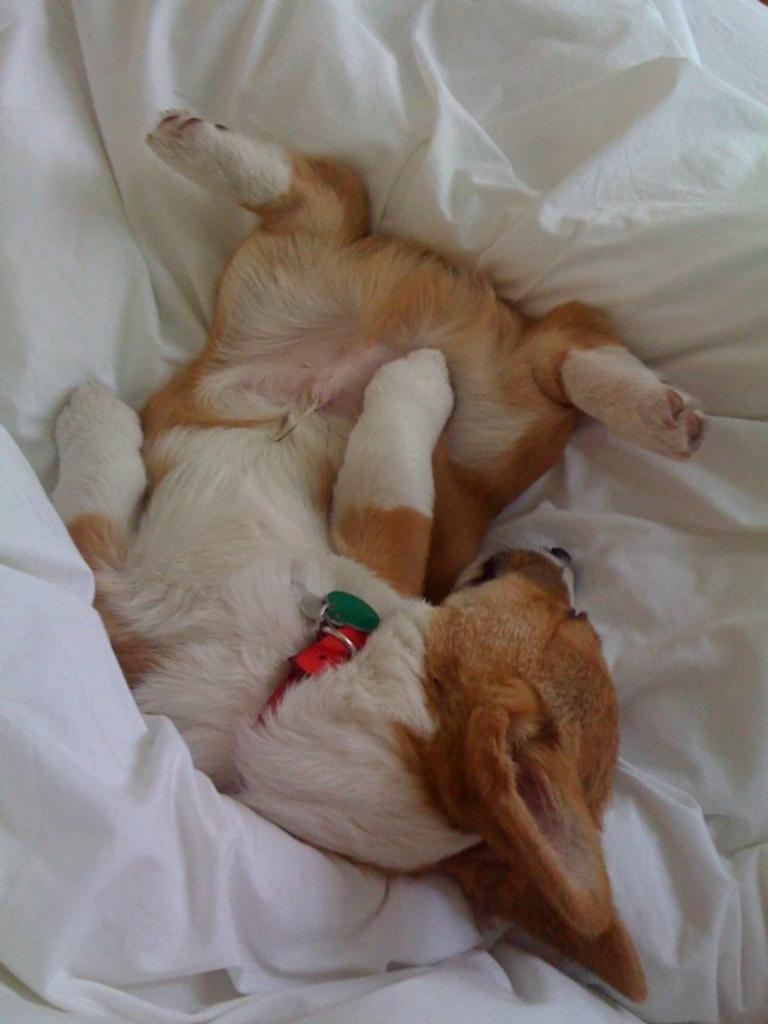What type of animal is in the image? There is a brown and white puppy in the image. What is the puppy sitting or lying on? The puppy is on a white bed sheet. How many chairs are visible in the image? There are no chairs visible in the image; it only features a brown and white puppy on a white bed sheet. Can you see any ladybugs in the image? There are no ladybugs present in the image. 